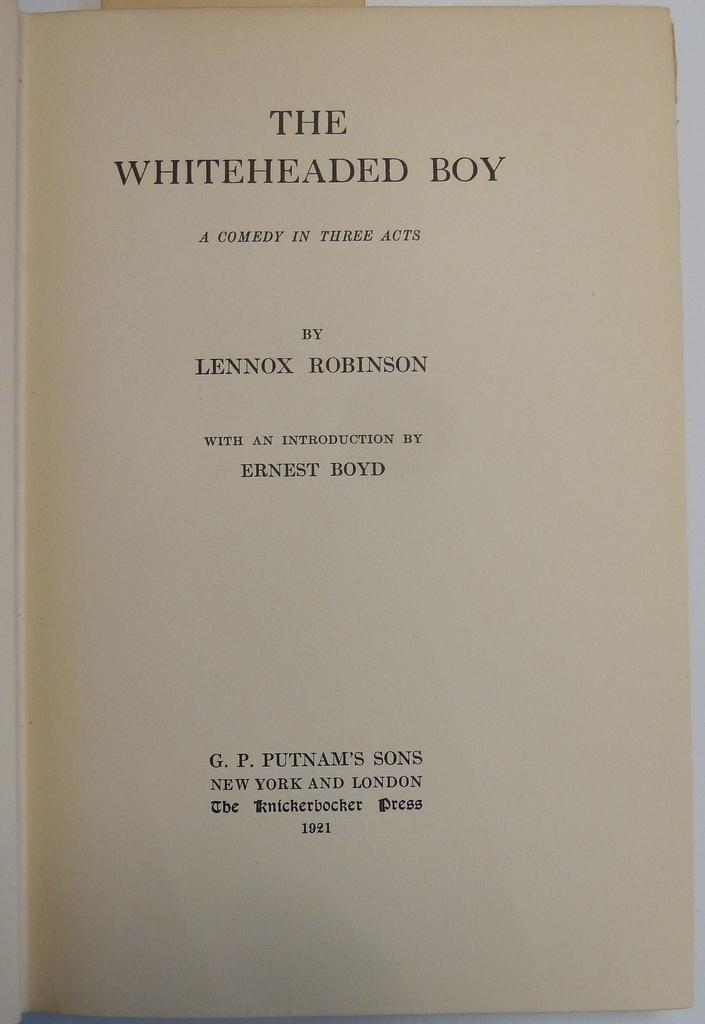<image>
Summarize the visual content of the image. The Lennox Robinson play The Whiteheaded Boy is a comedy in three acts. 